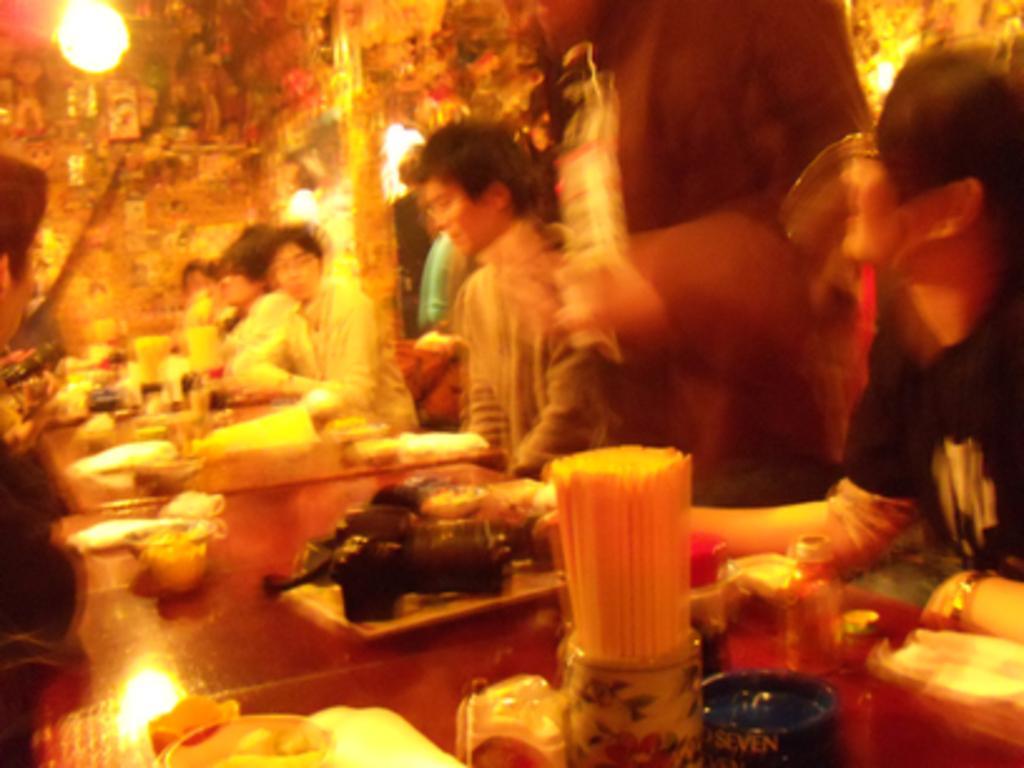Describe this image in one or two sentences. In this image I can see the blurry picture in which I can see number of persons are sitting around the dining table on which I can see few objects. I can see a person standing and few lights. 